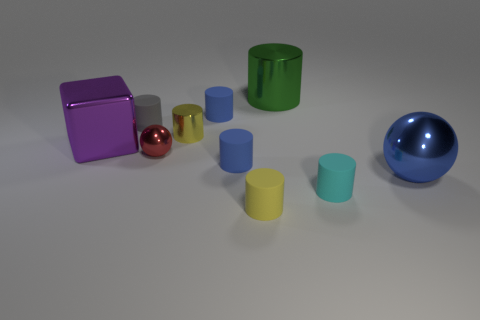Subtract all big green cylinders. How many cylinders are left? 6 Subtract all green cylinders. How many cylinders are left? 6 Subtract all spheres. How many objects are left? 8 Subtract all large blue metal things. Subtract all green cylinders. How many objects are left? 8 Add 4 gray matte cylinders. How many gray matte cylinders are left? 5 Add 7 big blue cylinders. How many big blue cylinders exist? 7 Subtract 0 cyan spheres. How many objects are left? 10 Subtract 1 blocks. How many blocks are left? 0 Subtract all purple spheres. Subtract all green blocks. How many spheres are left? 2 Subtract all purple blocks. How many yellow spheres are left? 0 